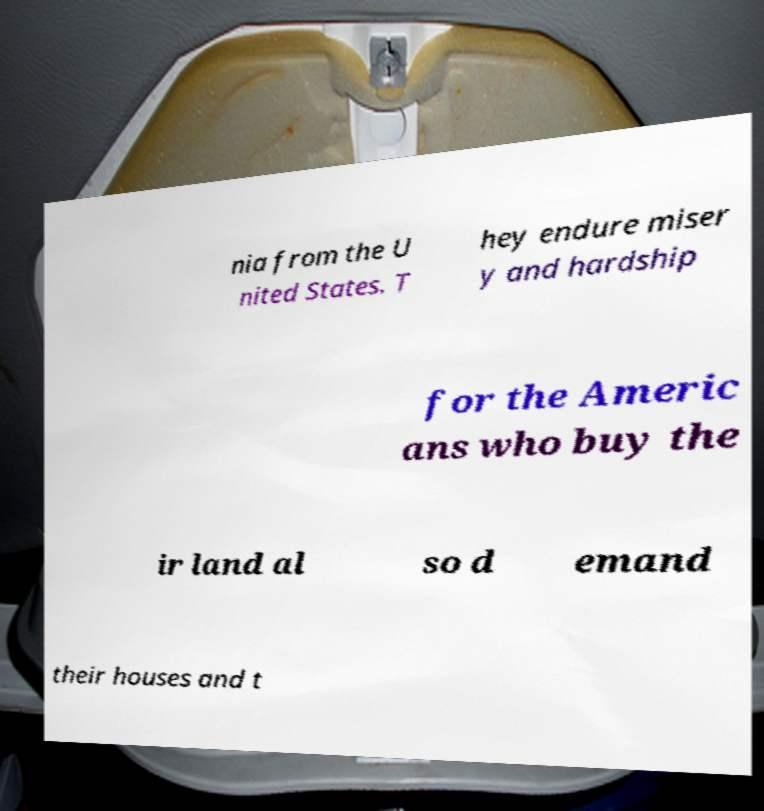Please read and relay the text visible in this image. What does it say? nia from the U nited States. T hey endure miser y and hardship for the Americ ans who buy the ir land al so d emand their houses and t 